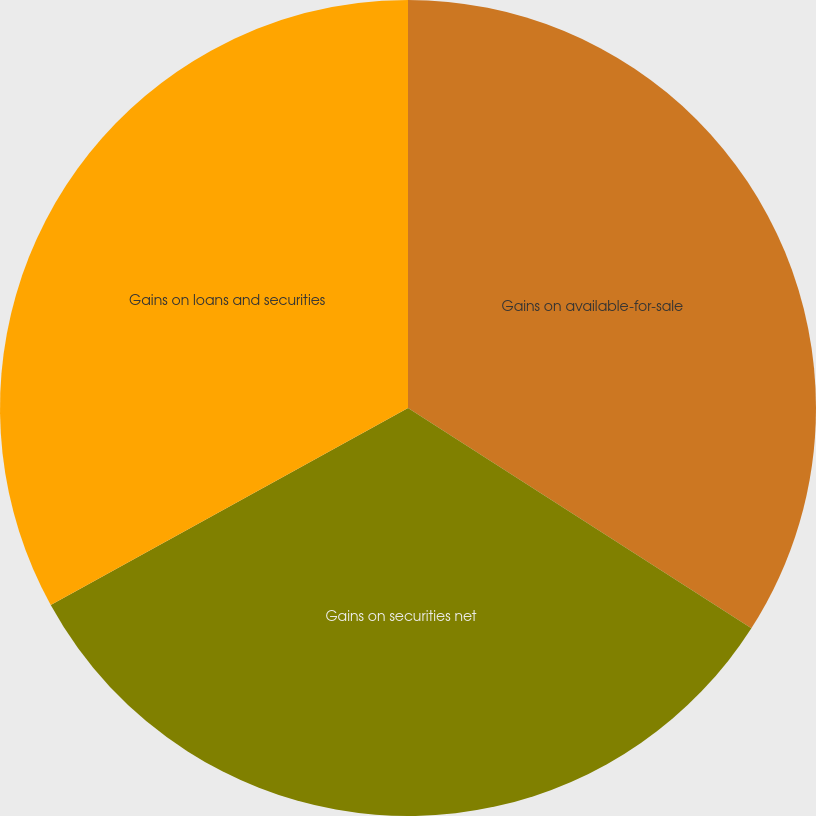<chart> <loc_0><loc_0><loc_500><loc_500><pie_chart><fcel>Gains on available-for-sale<fcel>Gains on securities net<fcel>Gains on loans and securities<nl><fcel>34.08%<fcel>32.9%<fcel>33.02%<nl></chart> 